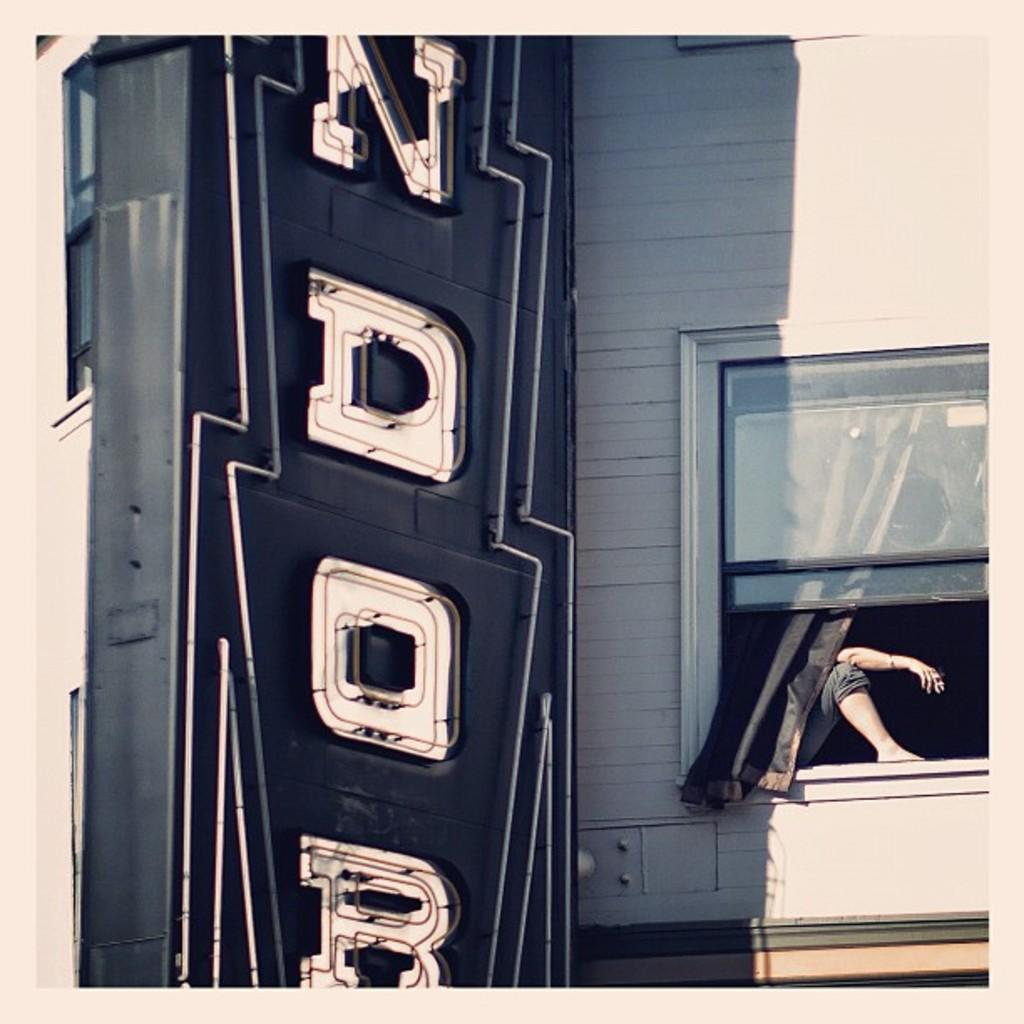What is the person in the image doing? There is a person sitting in a window in the image. What else can be seen in the image besides the person? There is a hoarding visible in the image. What type of trade is being conducted in the image? There is no trade being conducted in the image; it only shows a person sitting in a window and a hoarding. How does the person feel in the image? The image does not provide any information about the person's feelings or emotions. 